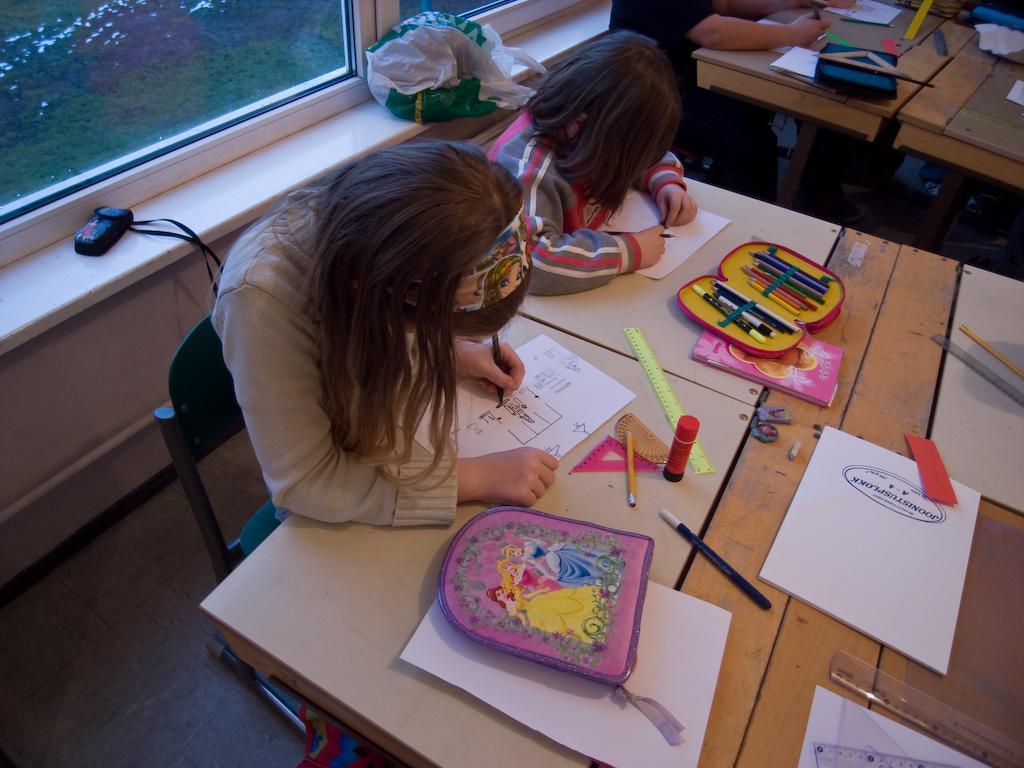Can you describe this image briefly? In this image i can see two persons sitting on a chair and writing in a paper on a table, there are few mens, gym, bag ,paper on a table, at right there is other person sitting and writing in a paper t the background i can see a window, cover. 